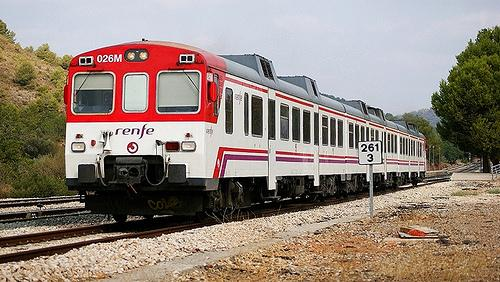What company name or logo is visible on the train? The blue word "renfe" is visible on the train. Count the number of square windows visible in the image. There are six square windows visible in the image. Name the primary colors used to depict the train. The train is predominantly red and white, with hints of burgundy and blue in the logo. Examine the sign located next to the train; what two colors is it? The sign next to the train is white and black. What type of transportation is featured in the image? The image features a red and white train as the main mode of transportation. Identify the elements that contribute to the sentiment of this image. The gray cloudy sky, the red and white train, and the grassy surroundings contribute to the image's overall sentiment. Describe the type of weather observed in the image. The weather seems to be overcast, with a gray, cloudy sky. State the number and color seen printed on a sign in the image. The number 261 is printed on a sign in the image. Based on the elements present in the image, is it likely a sunny day or a cloudy day? It is likely a cloudy day, considering the gray sky in the background. Provide a short description of the location that the image is set in. The image is set at a train station, featuring a red and white train on a track, surrounded by some grassy hills, trees, and a cloudy sky. Point out the tall building in the background, behind the train. There is no mention of any buildings in the list of objects and details in the image. This instruction is misleading because it requests the viewer to identify a non-existing building in the scene. Spot the small dog running across the train tracks. None of the details provided mention a dog or any animals in the image. This instruction is misleading because it implies there is an animal in the scene when there isn't. Can you notice the bright pink logo on the side of the train? This instruction is misleading because no information is given about a pink logo on the train. The logos mentioned include a burgundy print, a burgundy circular design, blue word "renfe," and a white horn, but nothing regarding a pink logo. Discover where the brown, wooden bench is located near the train tracks. The information provided does not mention a bench or any seating in the vicinity of the train tracks. This instruction is misleading because it asks the viewer to find a non-existent object in the image. Find the blue and green bus parked next to the train. There is no mention of a bus in the provided information, and therefore it is not present in the image. The instruction is misleading as it asks the viewer to locate a non-existent object. Is there a rainbow visible in the cloudy sky? The sky in the image is described as gray or cloudy, with no mention of any rainbows. This instruction is misleading because it suggests there could be a rainbow present in the cloudy conditions when there isn't any reference to it in the information provided. 